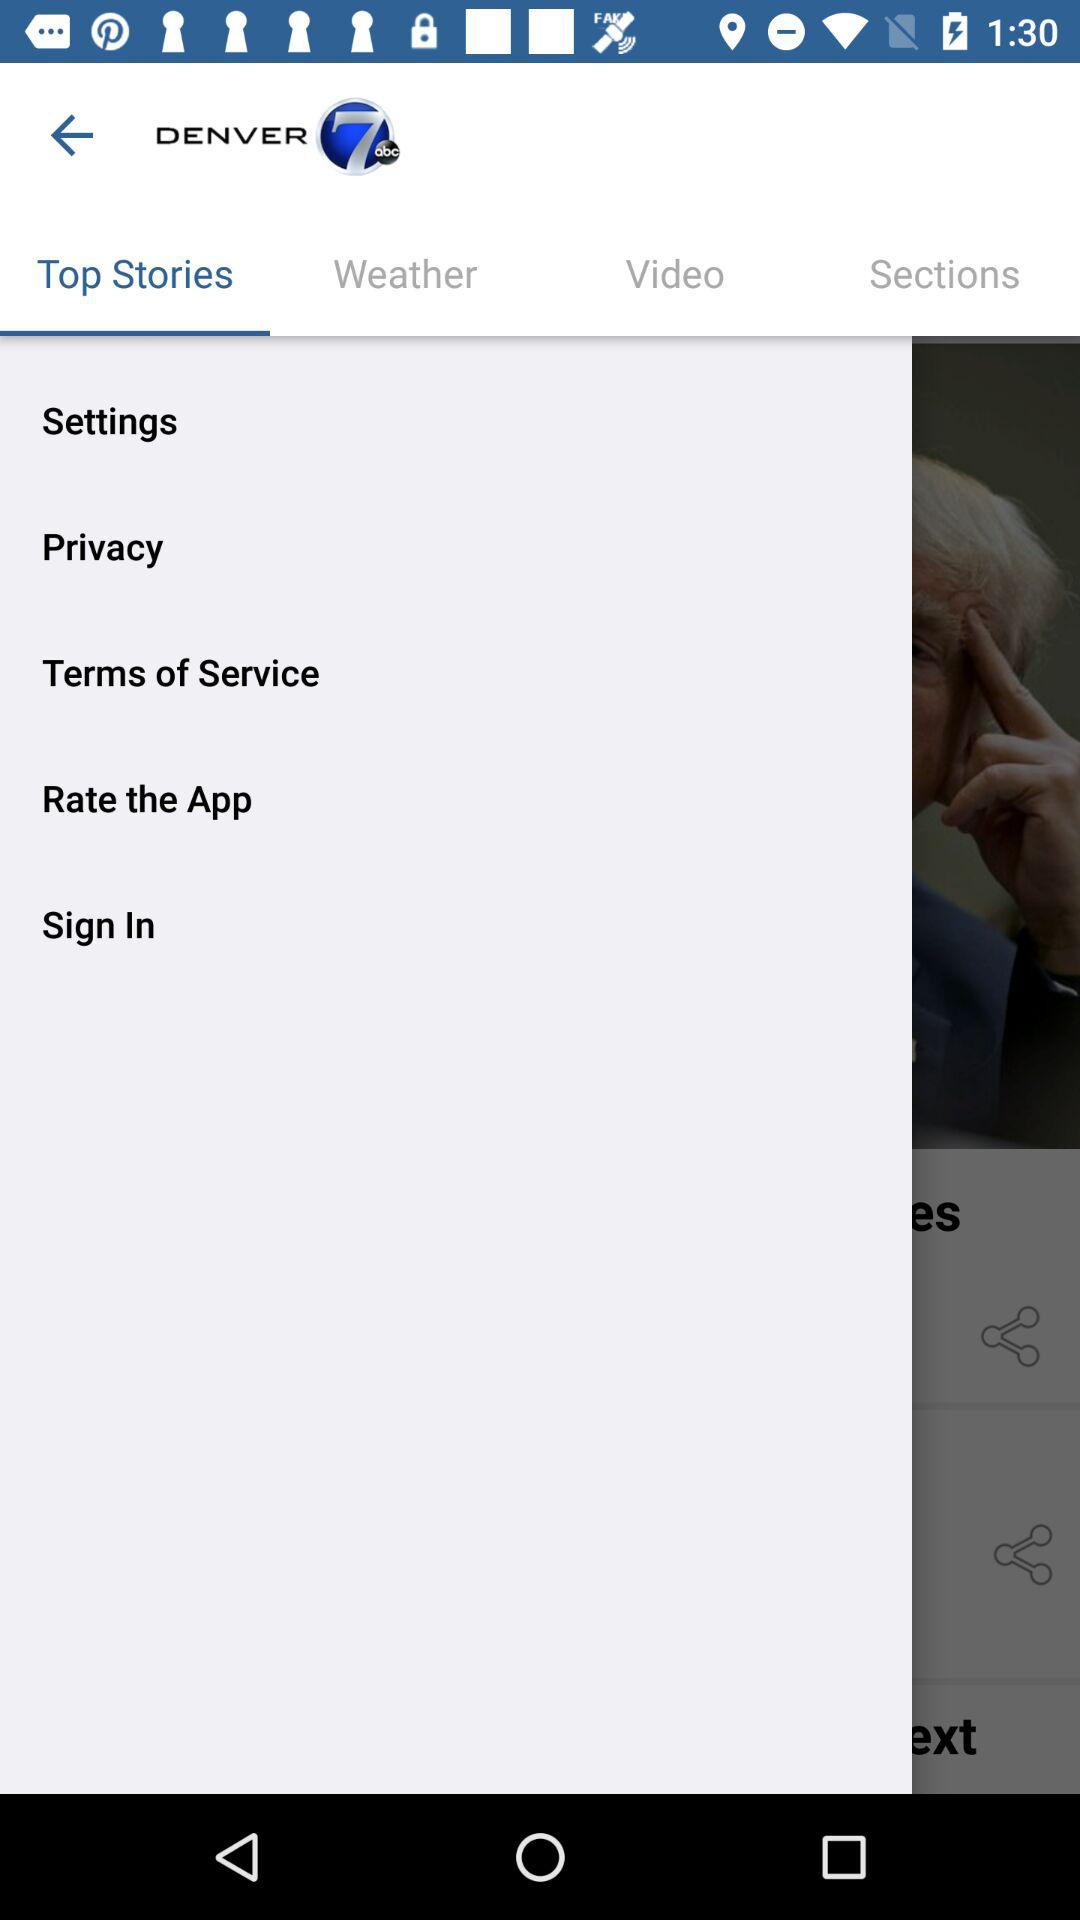What is the name of the application? The name of the application is "Denver7". 